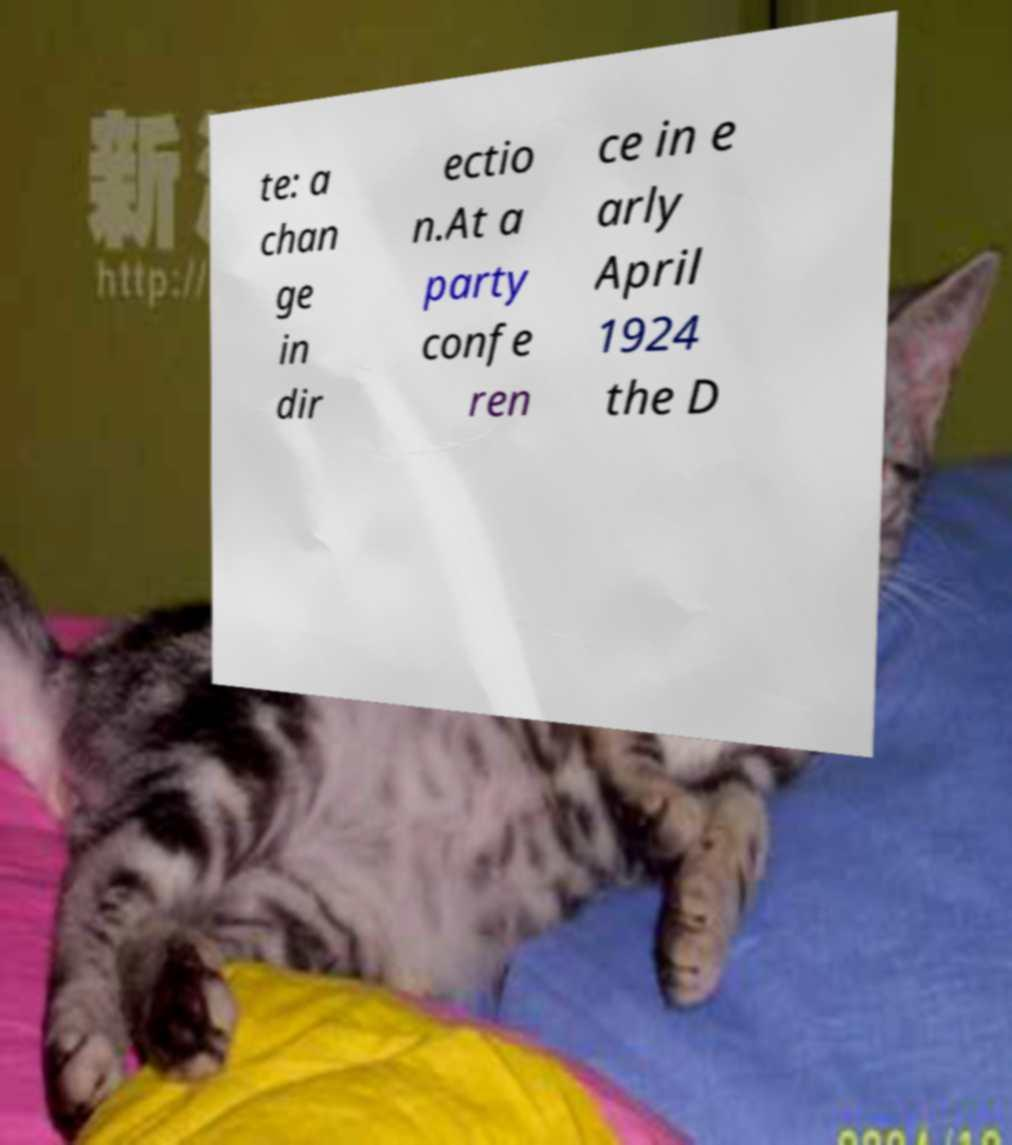I need the written content from this picture converted into text. Can you do that? te: a chan ge in dir ectio n.At a party confe ren ce in e arly April 1924 the D 